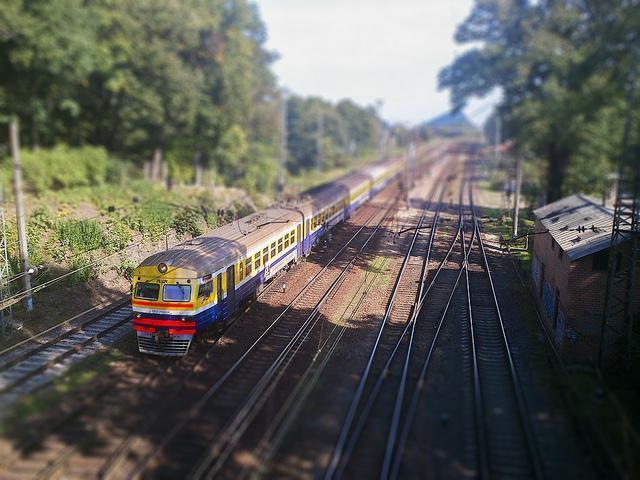How many people are wearing blue hats?
Give a very brief answer. 0. 